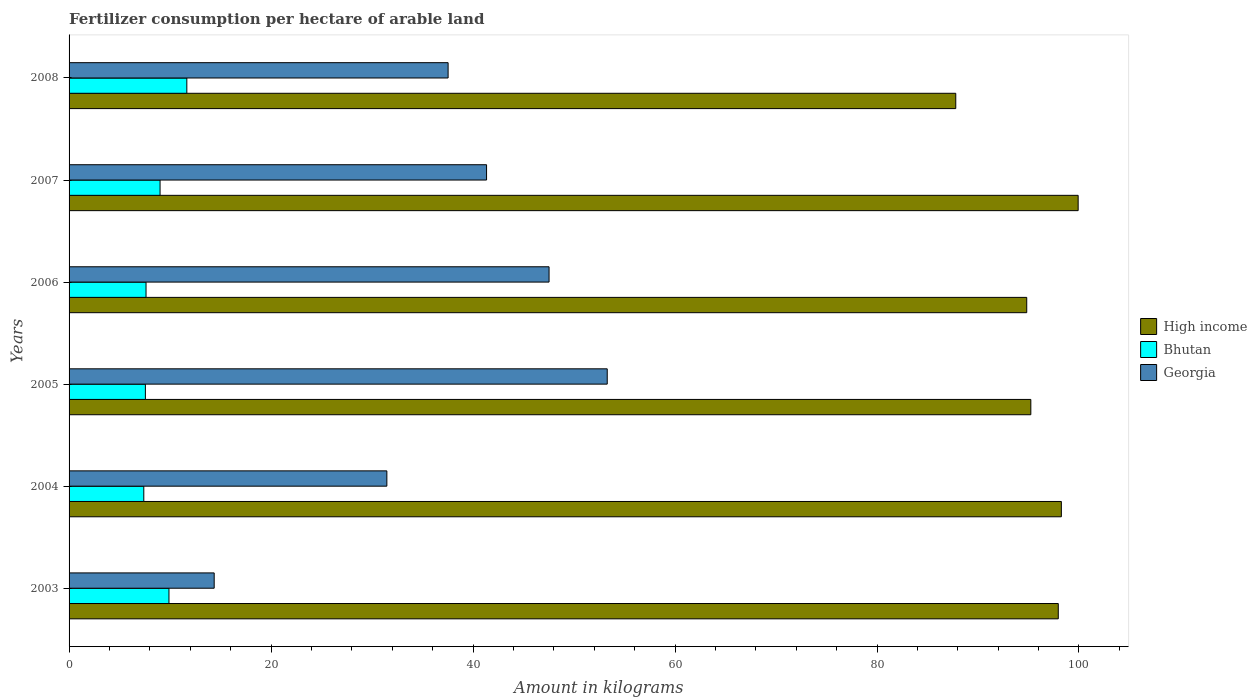How many different coloured bars are there?
Your answer should be compact. 3. How many groups of bars are there?
Provide a succinct answer. 6. How many bars are there on the 2nd tick from the top?
Your answer should be very brief. 3. What is the label of the 2nd group of bars from the top?
Your response must be concise. 2007. What is the amount of fertilizer consumption in High income in 2008?
Offer a terse response. 87.8. Across all years, what is the maximum amount of fertilizer consumption in Georgia?
Provide a short and direct response. 53.29. Across all years, what is the minimum amount of fertilizer consumption in High income?
Provide a short and direct response. 87.8. What is the total amount of fertilizer consumption in High income in the graph?
Ensure brevity in your answer.  573.98. What is the difference between the amount of fertilizer consumption in Bhutan in 2003 and that in 2008?
Make the answer very short. -1.77. What is the difference between the amount of fertilizer consumption in Bhutan in 2005 and the amount of fertilizer consumption in Georgia in 2003?
Make the answer very short. -6.81. What is the average amount of fertilizer consumption in Georgia per year?
Your answer should be very brief. 37.59. In the year 2003, what is the difference between the amount of fertilizer consumption in High income and amount of fertilizer consumption in Georgia?
Provide a succinct answer. 83.58. In how many years, is the amount of fertilizer consumption in Georgia greater than 84 kg?
Ensure brevity in your answer.  0. What is the ratio of the amount of fertilizer consumption in High income in 2004 to that in 2007?
Give a very brief answer. 0.98. Is the amount of fertilizer consumption in Georgia in 2003 less than that in 2004?
Your answer should be compact. Yes. What is the difference between the highest and the second highest amount of fertilizer consumption in Bhutan?
Your answer should be very brief. 1.77. What is the difference between the highest and the lowest amount of fertilizer consumption in High income?
Make the answer very short. 12.12. In how many years, is the amount of fertilizer consumption in Bhutan greater than the average amount of fertilizer consumption in Bhutan taken over all years?
Your answer should be very brief. 3. Is the sum of the amount of fertilizer consumption in Georgia in 2004 and 2008 greater than the maximum amount of fertilizer consumption in Bhutan across all years?
Offer a very short reply. Yes. What does the 1st bar from the top in 2007 represents?
Provide a short and direct response. Georgia. Is it the case that in every year, the sum of the amount of fertilizer consumption in High income and amount of fertilizer consumption in Georgia is greater than the amount of fertilizer consumption in Bhutan?
Make the answer very short. Yes. How many bars are there?
Your answer should be compact. 18. Are all the bars in the graph horizontal?
Provide a short and direct response. Yes. What is the difference between two consecutive major ticks on the X-axis?
Your response must be concise. 20. Does the graph contain any zero values?
Your response must be concise. No. How many legend labels are there?
Keep it short and to the point. 3. How are the legend labels stacked?
Your answer should be compact. Vertical. What is the title of the graph?
Make the answer very short. Fertilizer consumption per hectare of arable land. Does "Ethiopia" appear as one of the legend labels in the graph?
Ensure brevity in your answer.  No. What is the label or title of the X-axis?
Offer a very short reply. Amount in kilograms. What is the label or title of the Y-axis?
Your answer should be compact. Years. What is the Amount in kilograms in High income in 2003?
Your response must be concise. 97.95. What is the Amount in kilograms in Bhutan in 2003?
Give a very brief answer. 9.89. What is the Amount in kilograms in Georgia in 2003?
Your response must be concise. 14.37. What is the Amount in kilograms of High income in 2004?
Offer a terse response. 98.26. What is the Amount in kilograms in Bhutan in 2004?
Ensure brevity in your answer.  7.4. What is the Amount in kilograms in Georgia in 2004?
Your response must be concise. 31.47. What is the Amount in kilograms in High income in 2005?
Your answer should be compact. 95.23. What is the Amount in kilograms in Bhutan in 2005?
Your answer should be very brief. 7.56. What is the Amount in kilograms of Georgia in 2005?
Your answer should be very brief. 53.29. What is the Amount in kilograms of High income in 2006?
Give a very brief answer. 94.83. What is the Amount in kilograms of Bhutan in 2006?
Provide a succinct answer. 7.62. What is the Amount in kilograms in Georgia in 2006?
Your answer should be compact. 47.53. What is the Amount in kilograms in High income in 2007?
Your answer should be compact. 99.92. What is the Amount in kilograms in Bhutan in 2007?
Make the answer very short. 9.01. What is the Amount in kilograms of Georgia in 2007?
Provide a succinct answer. 41.34. What is the Amount in kilograms of High income in 2008?
Provide a succinct answer. 87.8. What is the Amount in kilograms of Bhutan in 2008?
Your response must be concise. 11.66. What is the Amount in kilograms of Georgia in 2008?
Provide a short and direct response. 37.53. Across all years, what is the maximum Amount in kilograms of High income?
Your answer should be very brief. 99.92. Across all years, what is the maximum Amount in kilograms of Bhutan?
Your answer should be very brief. 11.66. Across all years, what is the maximum Amount in kilograms in Georgia?
Ensure brevity in your answer.  53.29. Across all years, what is the minimum Amount in kilograms of High income?
Give a very brief answer. 87.8. Across all years, what is the minimum Amount in kilograms in Bhutan?
Keep it short and to the point. 7.4. Across all years, what is the minimum Amount in kilograms of Georgia?
Give a very brief answer. 14.37. What is the total Amount in kilograms of High income in the graph?
Your answer should be compact. 573.98. What is the total Amount in kilograms of Bhutan in the graph?
Your response must be concise. 53.14. What is the total Amount in kilograms of Georgia in the graph?
Ensure brevity in your answer.  225.52. What is the difference between the Amount in kilograms in High income in 2003 and that in 2004?
Provide a succinct answer. -0.31. What is the difference between the Amount in kilograms of Bhutan in 2003 and that in 2004?
Offer a very short reply. 2.49. What is the difference between the Amount in kilograms of Georgia in 2003 and that in 2004?
Offer a terse response. -17.1. What is the difference between the Amount in kilograms in High income in 2003 and that in 2005?
Make the answer very short. 2.72. What is the difference between the Amount in kilograms in Bhutan in 2003 and that in 2005?
Offer a terse response. 2.33. What is the difference between the Amount in kilograms in Georgia in 2003 and that in 2005?
Provide a short and direct response. -38.92. What is the difference between the Amount in kilograms in High income in 2003 and that in 2006?
Give a very brief answer. 3.12. What is the difference between the Amount in kilograms in Bhutan in 2003 and that in 2006?
Make the answer very short. 2.27. What is the difference between the Amount in kilograms in Georgia in 2003 and that in 2006?
Your answer should be compact. -33.16. What is the difference between the Amount in kilograms of High income in 2003 and that in 2007?
Give a very brief answer. -1.97. What is the difference between the Amount in kilograms of Bhutan in 2003 and that in 2007?
Your answer should be very brief. 0.88. What is the difference between the Amount in kilograms in Georgia in 2003 and that in 2007?
Provide a succinct answer. -26.97. What is the difference between the Amount in kilograms of High income in 2003 and that in 2008?
Your answer should be very brief. 10.15. What is the difference between the Amount in kilograms of Bhutan in 2003 and that in 2008?
Provide a succinct answer. -1.77. What is the difference between the Amount in kilograms in Georgia in 2003 and that in 2008?
Your answer should be very brief. -23.16. What is the difference between the Amount in kilograms of High income in 2004 and that in 2005?
Keep it short and to the point. 3.02. What is the difference between the Amount in kilograms of Bhutan in 2004 and that in 2005?
Provide a succinct answer. -0.16. What is the difference between the Amount in kilograms in Georgia in 2004 and that in 2005?
Your answer should be compact. -21.82. What is the difference between the Amount in kilograms of High income in 2004 and that in 2006?
Provide a short and direct response. 3.43. What is the difference between the Amount in kilograms in Bhutan in 2004 and that in 2006?
Your answer should be compact. -0.22. What is the difference between the Amount in kilograms of Georgia in 2004 and that in 2006?
Offer a terse response. -16.06. What is the difference between the Amount in kilograms of High income in 2004 and that in 2007?
Ensure brevity in your answer.  -1.66. What is the difference between the Amount in kilograms in Bhutan in 2004 and that in 2007?
Your response must be concise. -1.61. What is the difference between the Amount in kilograms in Georgia in 2004 and that in 2007?
Offer a terse response. -9.87. What is the difference between the Amount in kilograms in High income in 2004 and that in 2008?
Provide a short and direct response. 10.46. What is the difference between the Amount in kilograms in Bhutan in 2004 and that in 2008?
Ensure brevity in your answer.  -4.26. What is the difference between the Amount in kilograms of Georgia in 2004 and that in 2008?
Provide a short and direct response. -6.06. What is the difference between the Amount in kilograms of High income in 2005 and that in 2006?
Your response must be concise. 0.41. What is the difference between the Amount in kilograms in Bhutan in 2005 and that in 2006?
Make the answer very short. -0.06. What is the difference between the Amount in kilograms in Georgia in 2005 and that in 2006?
Your answer should be compact. 5.76. What is the difference between the Amount in kilograms in High income in 2005 and that in 2007?
Offer a very short reply. -4.69. What is the difference between the Amount in kilograms in Bhutan in 2005 and that in 2007?
Offer a very short reply. -1.45. What is the difference between the Amount in kilograms of Georgia in 2005 and that in 2007?
Your answer should be compact. 11.95. What is the difference between the Amount in kilograms of High income in 2005 and that in 2008?
Your answer should be compact. 7.43. What is the difference between the Amount in kilograms in Bhutan in 2005 and that in 2008?
Make the answer very short. -4.1. What is the difference between the Amount in kilograms of Georgia in 2005 and that in 2008?
Keep it short and to the point. 15.76. What is the difference between the Amount in kilograms in High income in 2006 and that in 2007?
Ensure brevity in your answer.  -5.09. What is the difference between the Amount in kilograms of Bhutan in 2006 and that in 2007?
Your answer should be very brief. -1.39. What is the difference between the Amount in kilograms of Georgia in 2006 and that in 2007?
Provide a succinct answer. 6.19. What is the difference between the Amount in kilograms of High income in 2006 and that in 2008?
Your response must be concise. 7.03. What is the difference between the Amount in kilograms in Bhutan in 2006 and that in 2008?
Ensure brevity in your answer.  -4.04. What is the difference between the Amount in kilograms in Georgia in 2006 and that in 2008?
Offer a very short reply. 10. What is the difference between the Amount in kilograms in High income in 2007 and that in 2008?
Offer a terse response. 12.12. What is the difference between the Amount in kilograms of Bhutan in 2007 and that in 2008?
Ensure brevity in your answer.  -2.65. What is the difference between the Amount in kilograms of Georgia in 2007 and that in 2008?
Provide a short and direct response. 3.81. What is the difference between the Amount in kilograms of High income in 2003 and the Amount in kilograms of Bhutan in 2004?
Ensure brevity in your answer.  90.55. What is the difference between the Amount in kilograms of High income in 2003 and the Amount in kilograms of Georgia in 2004?
Make the answer very short. 66.48. What is the difference between the Amount in kilograms of Bhutan in 2003 and the Amount in kilograms of Georgia in 2004?
Provide a succinct answer. -21.57. What is the difference between the Amount in kilograms of High income in 2003 and the Amount in kilograms of Bhutan in 2005?
Provide a succinct answer. 90.39. What is the difference between the Amount in kilograms of High income in 2003 and the Amount in kilograms of Georgia in 2005?
Provide a short and direct response. 44.66. What is the difference between the Amount in kilograms of Bhutan in 2003 and the Amount in kilograms of Georgia in 2005?
Offer a terse response. -43.4. What is the difference between the Amount in kilograms of High income in 2003 and the Amount in kilograms of Bhutan in 2006?
Offer a very short reply. 90.33. What is the difference between the Amount in kilograms in High income in 2003 and the Amount in kilograms in Georgia in 2006?
Provide a succinct answer. 50.42. What is the difference between the Amount in kilograms of Bhutan in 2003 and the Amount in kilograms of Georgia in 2006?
Offer a terse response. -37.64. What is the difference between the Amount in kilograms in High income in 2003 and the Amount in kilograms in Bhutan in 2007?
Keep it short and to the point. 88.94. What is the difference between the Amount in kilograms in High income in 2003 and the Amount in kilograms in Georgia in 2007?
Offer a terse response. 56.61. What is the difference between the Amount in kilograms in Bhutan in 2003 and the Amount in kilograms in Georgia in 2007?
Your response must be concise. -31.45. What is the difference between the Amount in kilograms in High income in 2003 and the Amount in kilograms in Bhutan in 2008?
Your answer should be compact. 86.29. What is the difference between the Amount in kilograms of High income in 2003 and the Amount in kilograms of Georgia in 2008?
Provide a short and direct response. 60.42. What is the difference between the Amount in kilograms of Bhutan in 2003 and the Amount in kilograms of Georgia in 2008?
Provide a succinct answer. -27.64. What is the difference between the Amount in kilograms in High income in 2004 and the Amount in kilograms in Bhutan in 2005?
Provide a short and direct response. 90.7. What is the difference between the Amount in kilograms in High income in 2004 and the Amount in kilograms in Georgia in 2005?
Offer a very short reply. 44.97. What is the difference between the Amount in kilograms in Bhutan in 2004 and the Amount in kilograms in Georgia in 2005?
Keep it short and to the point. -45.89. What is the difference between the Amount in kilograms of High income in 2004 and the Amount in kilograms of Bhutan in 2006?
Your answer should be compact. 90.63. What is the difference between the Amount in kilograms in High income in 2004 and the Amount in kilograms in Georgia in 2006?
Offer a very short reply. 50.73. What is the difference between the Amount in kilograms in Bhutan in 2004 and the Amount in kilograms in Georgia in 2006?
Keep it short and to the point. -40.13. What is the difference between the Amount in kilograms of High income in 2004 and the Amount in kilograms of Bhutan in 2007?
Keep it short and to the point. 89.25. What is the difference between the Amount in kilograms of High income in 2004 and the Amount in kilograms of Georgia in 2007?
Ensure brevity in your answer.  56.92. What is the difference between the Amount in kilograms in Bhutan in 2004 and the Amount in kilograms in Georgia in 2007?
Keep it short and to the point. -33.94. What is the difference between the Amount in kilograms in High income in 2004 and the Amount in kilograms in Bhutan in 2008?
Keep it short and to the point. 86.6. What is the difference between the Amount in kilograms in High income in 2004 and the Amount in kilograms in Georgia in 2008?
Offer a very short reply. 60.72. What is the difference between the Amount in kilograms in Bhutan in 2004 and the Amount in kilograms in Georgia in 2008?
Ensure brevity in your answer.  -30.13. What is the difference between the Amount in kilograms of High income in 2005 and the Amount in kilograms of Bhutan in 2006?
Keep it short and to the point. 87.61. What is the difference between the Amount in kilograms in High income in 2005 and the Amount in kilograms in Georgia in 2006?
Your answer should be very brief. 47.7. What is the difference between the Amount in kilograms of Bhutan in 2005 and the Amount in kilograms of Georgia in 2006?
Your response must be concise. -39.97. What is the difference between the Amount in kilograms in High income in 2005 and the Amount in kilograms in Bhutan in 2007?
Offer a terse response. 86.22. What is the difference between the Amount in kilograms of High income in 2005 and the Amount in kilograms of Georgia in 2007?
Give a very brief answer. 53.89. What is the difference between the Amount in kilograms in Bhutan in 2005 and the Amount in kilograms in Georgia in 2007?
Your answer should be very brief. -33.78. What is the difference between the Amount in kilograms in High income in 2005 and the Amount in kilograms in Bhutan in 2008?
Your answer should be compact. 83.57. What is the difference between the Amount in kilograms of High income in 2005 and the Amount in kilograms of Georgia in 2008?
Offer a very short reply. 57.7. What is the difference between the Amount in kilograms of Bhutan in 2005 and the Amount in kilograms of Georgia in 2008?
Keep it short and to the point. -29.97. What is the difference between the Amount in kilograms in High income in 2006 and the Amount in kilograms in Bhutan in 2007?
Your answer should be very brief. 85.82. What is the difference between the Amount in kilograms of High income in 2006 and the Amount in kilograms of Georgia in 2007?
Offer a very short reply. 53.49. What is the difference between the Amount in kilograms in Bhutan in 2006 and the Amount in kilograms in Georgia in 2007?
Ensure brevity in your answer.  -33.72. What is the difference between the Amount in kilograms of High income in 2006 and the Amount in kilograms of Bhutan in 2008?
Offer a terse response. 83.17. What is the difference between the Amount in kilograms of High income in 2006 and the Amount in kilograms of Georgia in 2008?
Your response must be concise. 57.29. What is the difference between the Amount in kilograms of Bhutan in 2006 and the Amount in kilograms of Georgia in 2008?
Provide a short and direct response. -29.91. What is the difference between the Amount in kilograms of High income in 2007 and the Amount in kilograms of Bhutan in 2008?
Give a very brief answer. 88.26. What is the difference between the Amount in kilograms in High income in 2007 and the Amount in kilograms in Georgia in 2008?
Keep it short and to the point. 62.39. What is the difference between the Amount in kilograms in Bhutan in 2007 and the Amount in kilograms in Georgia in 2008?
Give a very brief answer. -28.52. What is the average Amount in kilograms of High income per year?
Provide a short and direct response. 95.66. What is the average Amount in kilograms of Bhutan per year?
Your response must be concise. 8.86. What is the average Amount in kilograms in Georgia per year?
Keep it short and to the point. 37.59. In the year 2003, what is the difference between the Amount in kilograms in High income and Amount in kilograms in Bhutan?
Offer a terse response. 88.06. In the year 2003, what is the difference between the Amount in kilograms of High income and Amount in kilograms of Georgia?
Your response must be concise. 83.58. In the year 2003, what is the difference between the Amount in kilograms of Bhutan and Amount in kilograms of Georgia?
Offer a very short reply. -4.48. In the year 2004, what is the difference between the Amount in kilograms in High income and Amount in kilograms in Bhutan?
Keep it short and to the point. 90.86. In the year 2004, what is the difference between the Amount in kilograms of High income and Amount in kilograms of Georgia?
Offer a terse response. 66.79. In the year 2004, what is the difference between the Amount in kilograms of Bhutan and Amount in kilograms of Georgia?
Make the answer very short. -24.07. In the year 2005, what is the difference between the Amount in kilograms in High income and Amount in kilograms in Bhutan?
Your answer should be compact. 87.67. In the year 2005, what is the difference between the Amount in kilograms in High income and Amount in kilograms in Georgia?
Your answer should be very brief. 41.94. In the year 2005, what is the difference between the Amount in kilograms of Bhutan and Amount in kilograms of Georgia?
Provide a succinct answer. -45.73. In the year 2006, what is the difference between the Amount in kilograms of High income and Amount in kilograms of Bhutan?
Your answer should be very brief. 87.21. In the year 2006, what is the difference between the Amount in kilograms in High income and Amount in kilograms in Georgia?
Your answer should be very brief. 47.3. In the year 2006, what is the difference between the Amount in kilograms of Bhutan and Amount in kilograms of Georgia?
Provide a short and direct response. -39.91. In the year 2007, what is the difference between the Amount in kilograms of High income and Amount in kilograms of Bhutan?
Your response must be concise. 90.91. In the year 2007, what is the difference between the Amount in kilograms in High income and Amount in kilograms in Georgia?
Give a very brief answer. 58.58. In the year 2007, what is the difference between the Amount in kilograms of Bhutan and Amount in kilograms of Georgia?
Keep it short and to the point. -32.33. In the year 2008, what is the difference between the Amount in kilograms in High income and Amount in kilograms in Bhutan?
Offer a terse response. 76.14. In the year 2008, what is the difference between the Amount in kilograms in High income and Amount in kilograms in Georgia?
Make the answer very short. 50.27. In the year 2008, what is the difference between the Amount in kilograms in Bhutan and Amount in kilograms in Georgia?
Provide a succinct answer. -25.87. What is the ratio of the Amount in kilograms of High income in 2003 to that in 2004?
Keep it short and to the point. 1. What is the ratio of the Amount in kilograms of Bhutan in 2003 to that in 2004?
Make the answer very short. 1.34. What is the ratio of the Amount in kilograms in Georgia in 2003 to that in 2004?
Offer a terse response. 0.46. What is the ratio of the Amount in kilograms in High income in 2003 to that in 2005?
Make the answer very short. 1.03. What is the ratio of the Amount in kilograms in Bhutan in 2003 to that in 2005?
Your response must be concise. 1.31. What is the ratio of the Amount in kilograms of Georgia in 2003 to that in 2005?
Offer a very short reply. 0.27. What is the ratio of the Amount in kilograms in High income in 2003 to that in 2006?
Your answer should be compact. 1.03. What is the ratio of the Amount in kilograms in Bhutan in 2003 to that in 2006?
Your answer should be very brief. 1.3. What is the ratio of the Amount in kilograms of Georgia in 2003 to that in 2006?
Make the answer very short. 0.3. What is the ratio of the Amount in kilograms of High income in 2003 to that in 2007?
Your response must be concise. 0.98. What is the ratio of the Amount in kilograms in Bhutan in 2003 to that in 2007?
Offer a terse response. 1.1. What is the ratio of the Amount in kilograms of Georgia in 2003 to that in 2007?
Offer a very short reply. 0.35. What is the ratio of the Amount in kilograms in High income in 2003 to that in 2008?
Provide a succinct answer. 1.12. What is the ratio of the Amount in kilograms of Bhutan in 2003 to that in 2008?
Offer a very short reply. 0.85. What is the ratio of the Amount in kilograms of Georgia in 2003 to that in 2008?
Your answer should be very brief. 0.38. What is the ratio of the Amount in kilograms in High income in 2004 to that in 2005?
Offer a terse response. 1.03. What is the ratio of the Amount in kilograms of Bhutan in 2004 to that in 2005?
Offer a terse response. 0.98. What is the ratio of the Amount in kilograms in Georgia in 2004 to that in 2005?
Provide a succinct answer. 0.59. What is the ratio of the Amount in kilograms in High income in 2004 to that in 2006?
Give a very brief answer. 1.04. What is the ratio of the Amount in kilograms of Bhutan in 2004 to that in 2006?
Keep it short and to the point. 0.97. What is the ratio of the Amount in kilograms in Georgia in 2004 to that in 2006?
Offer a terse response. 0.66. What is the ratio of the Amount in kilograms in High income in 2004 to that in 2007?
Ensure brevity in your answer.  0.98. What is the ratio of the Amount in kilograms of Bhutan in 2004 to that in 2007?
Provide a succinct answer. 0.82. What is the ratio of the Amount in kilograms in Georgia in 2004 to that in 2007?
Provide a succinct answer. 0.76. What is the ratio of the Amount in kilograms of High income in 2004 to that in 2008?
Offer a very short reply. 1.12. What is the ratio of the Amount in kilograms in Bhutan in 2004 to that in 2008?
Provide a short and direct response. 0.63. What is the ratio of the Amount in kilograms of Georgia in 2004 to that in 2008?
Provide a short and direct response. 0.84. What is the ratio of the Amount in kilograms of High income in 2005 to that in 2006?
Your answer should be compact. 1. What is the ratio of the Amount in kilograms of Bhutan in 2005 to that in 2006?
Give a very brief answer. 0.99. What is the ratio of the Amount in kilograms of Georgia in 2005 to that in 2006?
Offer a terse response. 1.12. What is the ratio of the Amount in kilograms of High income in 2005 to that in 2007?
Offer a terse response. 0.95. What is the ratio of the Amount in kilograms in Bhutan in 2005 to that in 2007?
Provide a short and direct response. 0.84. What is the ratio of the Amount in kilograms of Georgia in 2005 to that in 2007?
Provide a short and direct response. 1.29. What is the ratio of the Amount in kilograms of High income in 2005 to that in 2008?
Give a very brief answer. 1.08. What is the ratio of the Amount in kilograms in Bhutan in 2005 to that in 2008?
Provide a short and direct response. 0.65. What is the ratio of the Amount in kilograms of Georgia in 2005 to that in 2008?
Provide a short and direct response. 1.42. What is the ratio of the Amount in kilograms of High income in 2006 to that in 2007?
Give a very brief answer. 0.95. What is the ratio of the Amount in kilograms in Bhutan in 2006 to that in 2007?
Your answer should be very brief. 0.85. What is the ratio of the Amount in kilograms of Georgia in 2006 to that in 2007?
Provide a succinct answer. 1.15. What is the ratio of the Amount in kilograms in High income in 2006 to that in 2008?
Your answer should be very brief. 1.08. What is the ratio of the Amount in kilograms in Bhutan in 2006 to that in 2008?
Provide a succinct answer. 0.65. What is the ratio of the Amount in kilograms of Georgia in 2006 to that in 2008?
Offer a very short reply. 1.27. What is the ratio of the Amount in kilograms in High income in 2007 to that in 2008?
Your answer should be compact. 1.14. What is the ratio of the Amount in kilograms of Bhutan in 2007 to that in 2008?
Your answer should be compact. 0.77. What is the ratio of the Amount in kilograms in Georgia in 2007 to that in 2008?
Keep it short and to the point. 1.1. What is the difference between the highest and the second highest Amount in kilograms of High income?
Ensure brevity in your answer.  1.66. What is the difference between the highest and the second highest Amount in kilograms of Bhutan?
Keep it short and to the point. 1.77. What is the difference between the highest and the second highest Amount in kilograms in Georgia?
Your response must be concise. 5.76. What is the difference between the highest and the lowest Amount in kilograms of High income?
Your answer should be compact. 12.12. What is the difference between the highest and the lowest Amount in kilograms of Bhutan?
Your answer should be very brief. 4.26. What is the difference between the highest and the lowest Amount in kilograms in Georgia?
Your response must be concise. 38.92. 